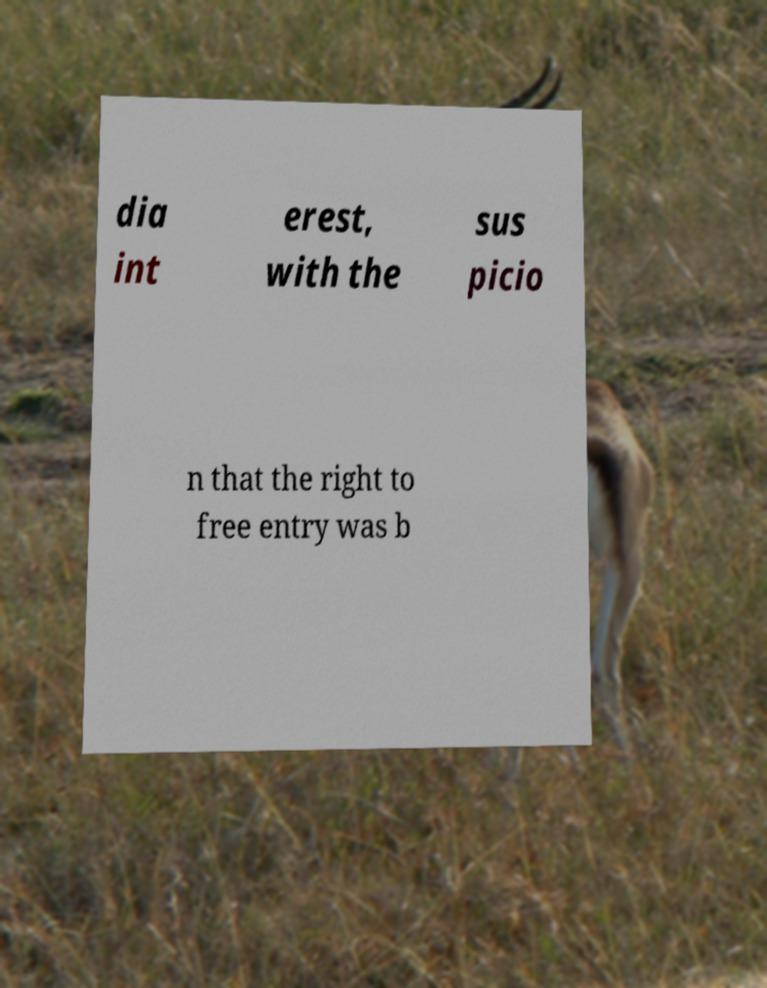What messages or text are displayed in this image? I need them in a readable, typed format. dia int erest, with the sus picio n that the right to free entry was b 